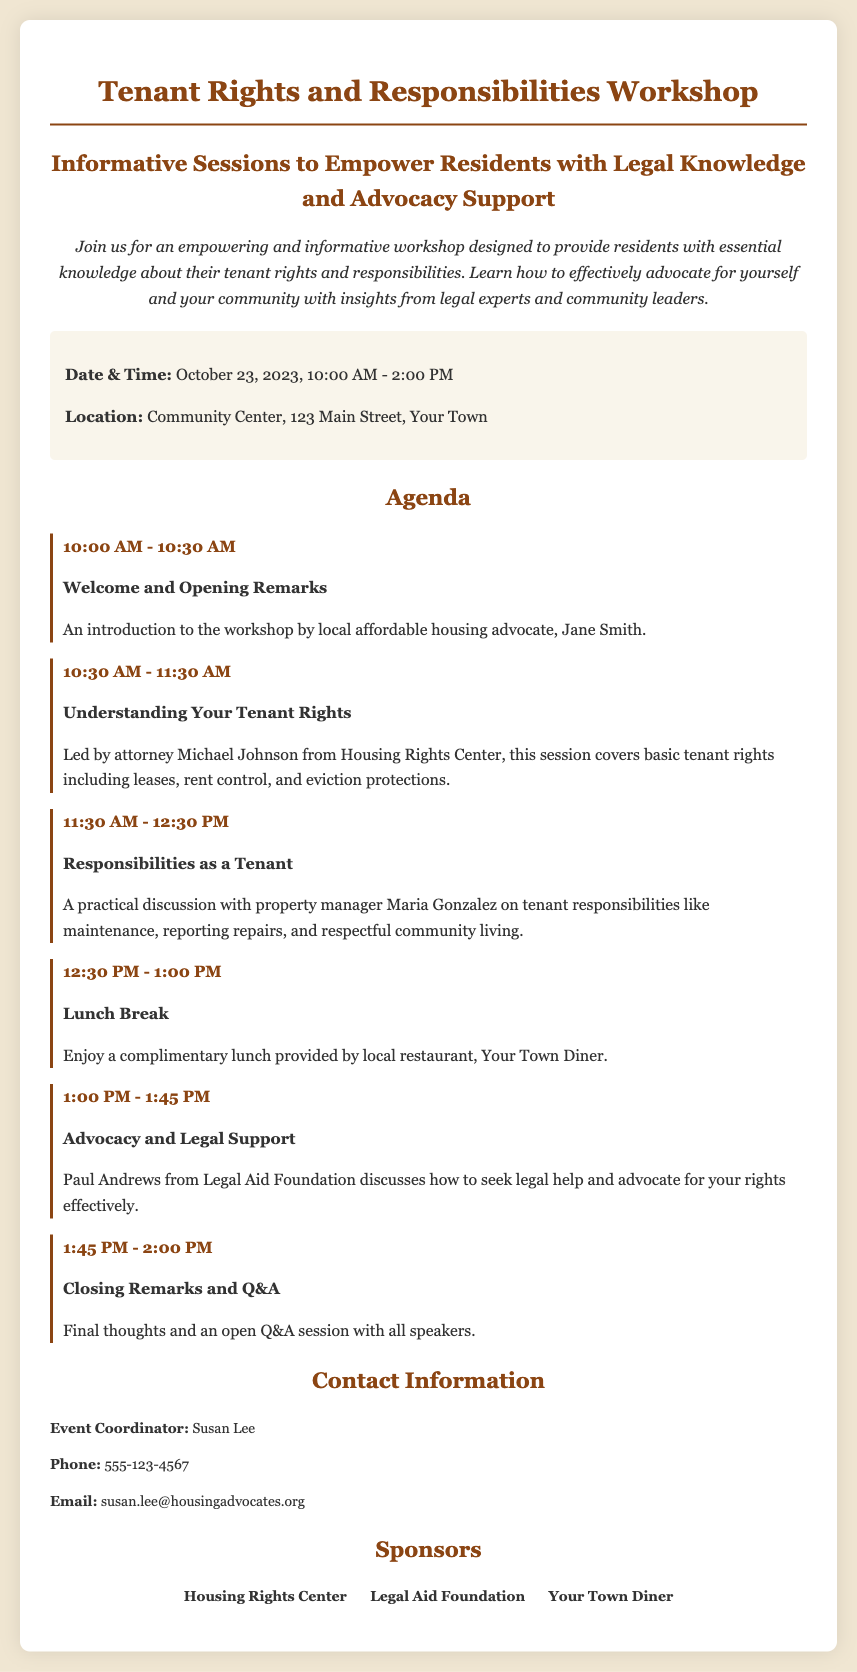What is the date of the workshop? The date of the workshop is listed in the details section of the document.
Answer: October 23, 2023 Who is leading the session on tenant rights? This information can be found in the agenda section of the document, where the session leaders are mentioned.
Answer: Michael Johnson What time does the lunch break start? The lunch break time can be found in the agenda where the time slots for each session are provided.
Answer: 12:30 PM Which restaurant is providing lunch? The document explicitly mentions the restaurant responsible for the complimentary lunch in the agenda section.
Answer: Your Town Diner What is the purpose of the workshop? The introduction section clearly describes the aim of the workshop.
Answer: Empower residents with legal knowledge and advocacy support Who will provide closing remarks? This information about the closing session is included in the agenda section of the document.
Answer: All speakers How long is the workshop? The overall duration of the event can be calculated based on the start and end times presented in the details section.
Answer: 4 hours What is the email address for the event coordinator? This is stated in the contact information section of the document.
Answer: susan.lee@housingadvocates.org What type of session is scheduled from 1:00 PM to 1:45 PM? This is described in the agenda where the topics of the sessions are listed with their corresponding times.
Answer: Advocacy and Legal Support 